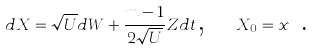<formula> <loc_0><loc_0><loc_500><loc_500>d X = \sqrt { U } d W + \frac { m - 1 } { 2 \sqrt { U } } Z d t \text {,} \quad X _ { 0 } = x \text { .}</formula> 